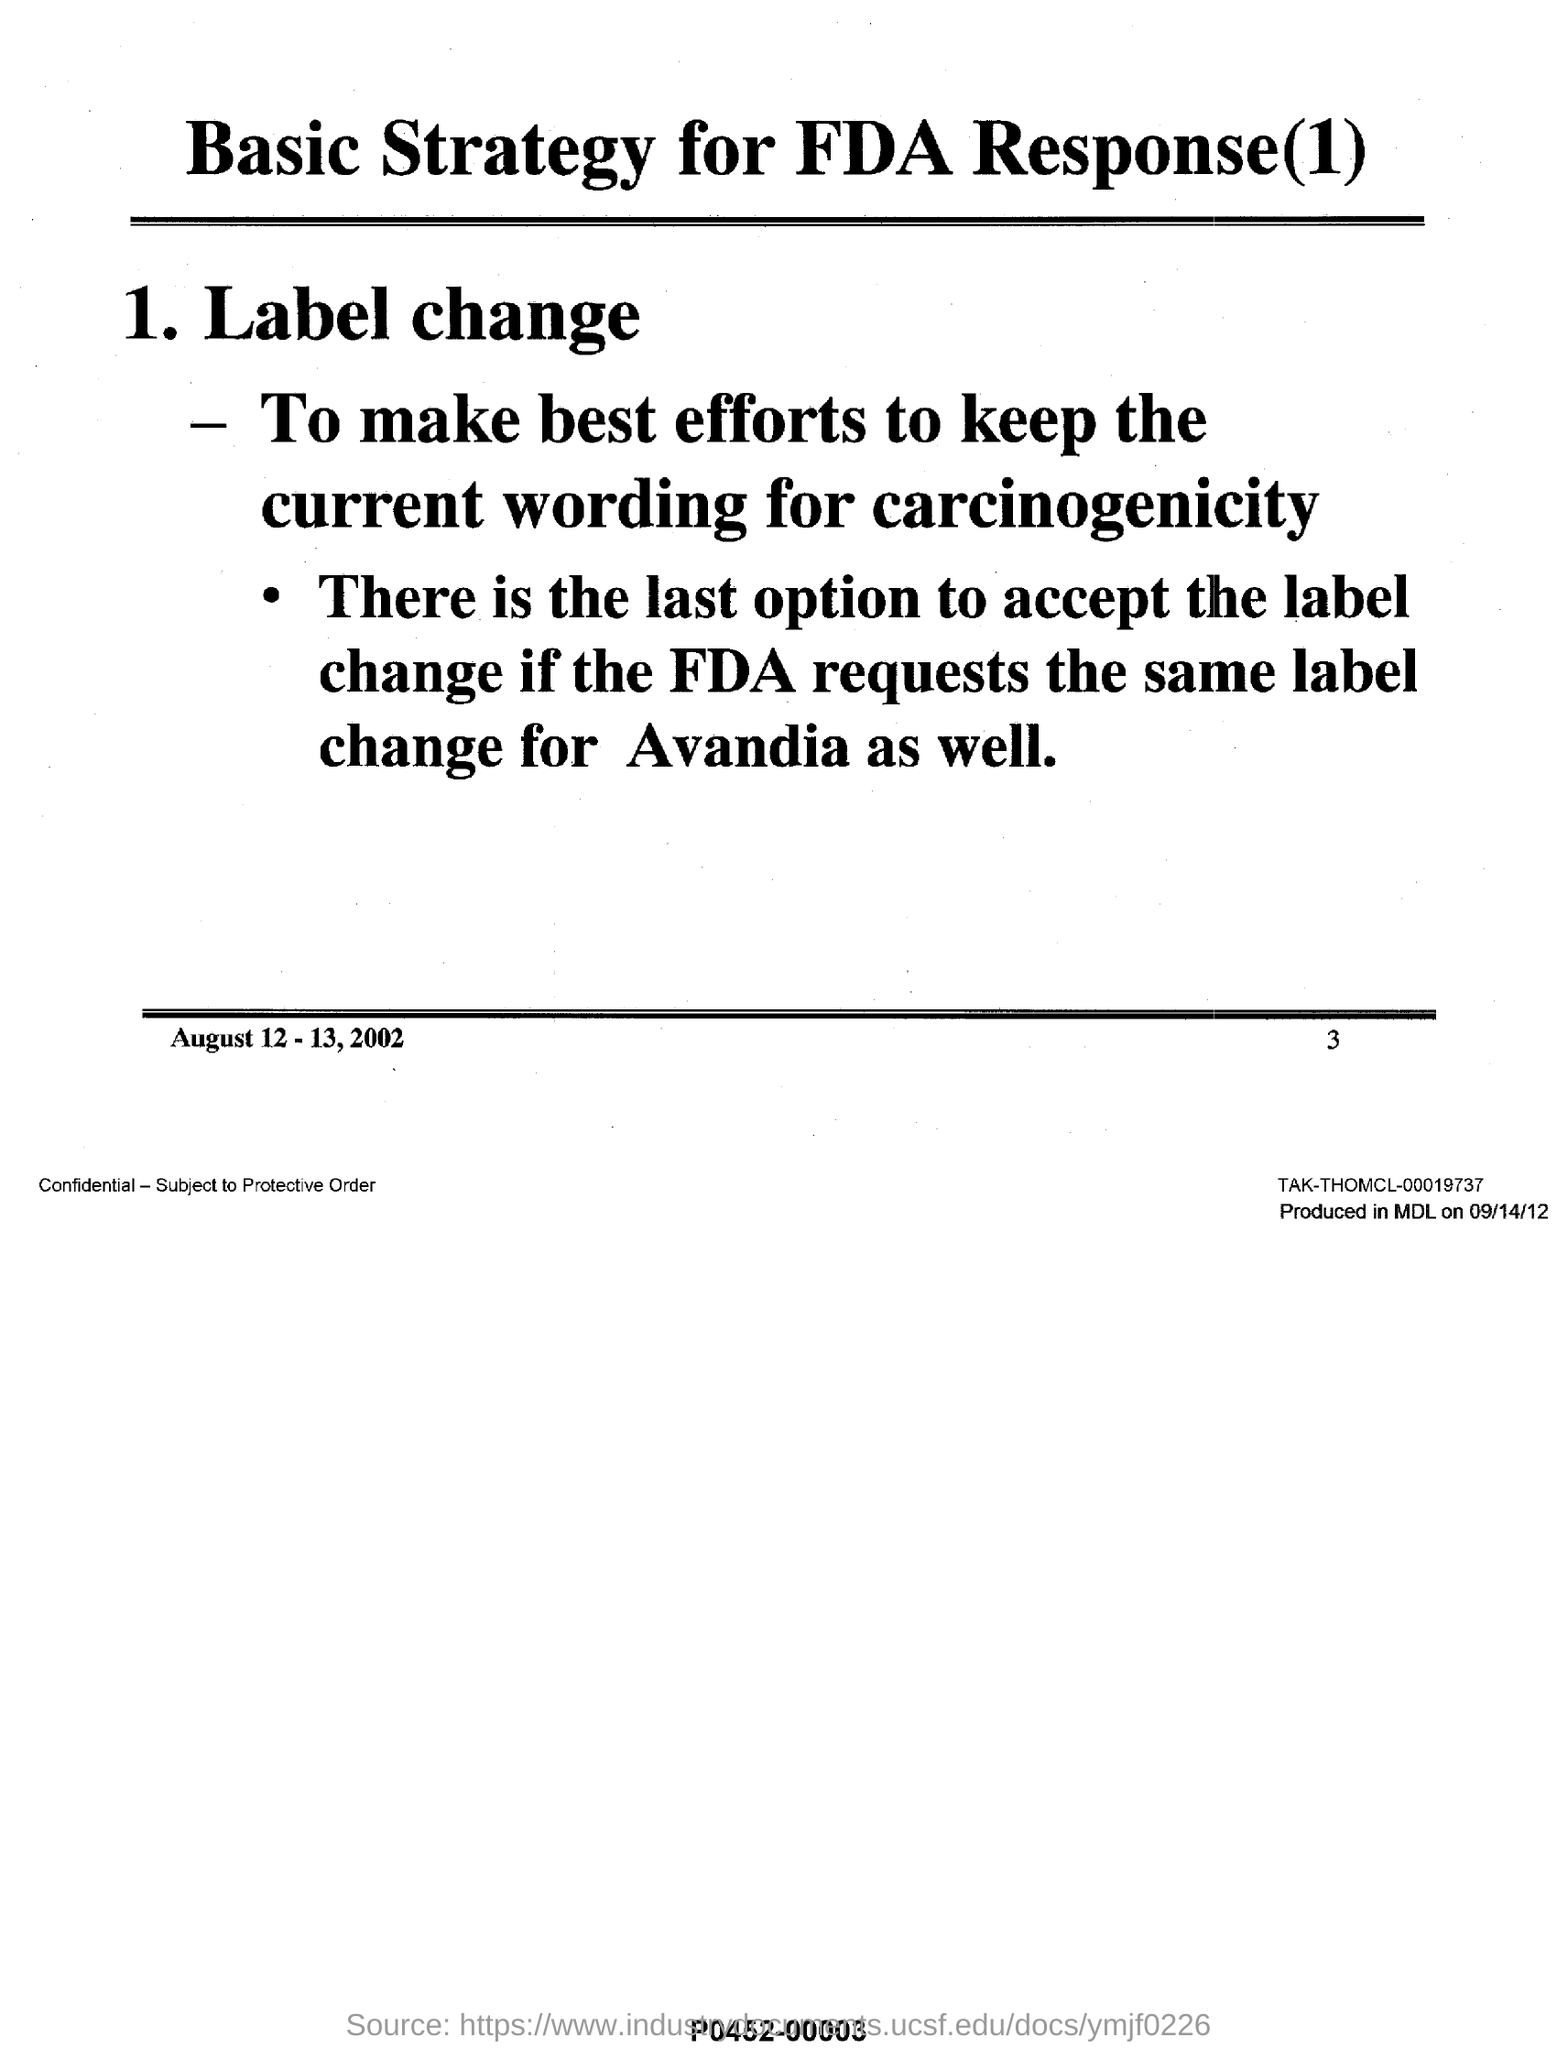Identify some key points in this picture. The first sub-heading in the document is 'Label Change.' The date mentioned in the document is August 12 and 13, 2002. The page number provided in the footer is 3. The document's heading is 'Basic Strategy for FDA Response(1).'. 